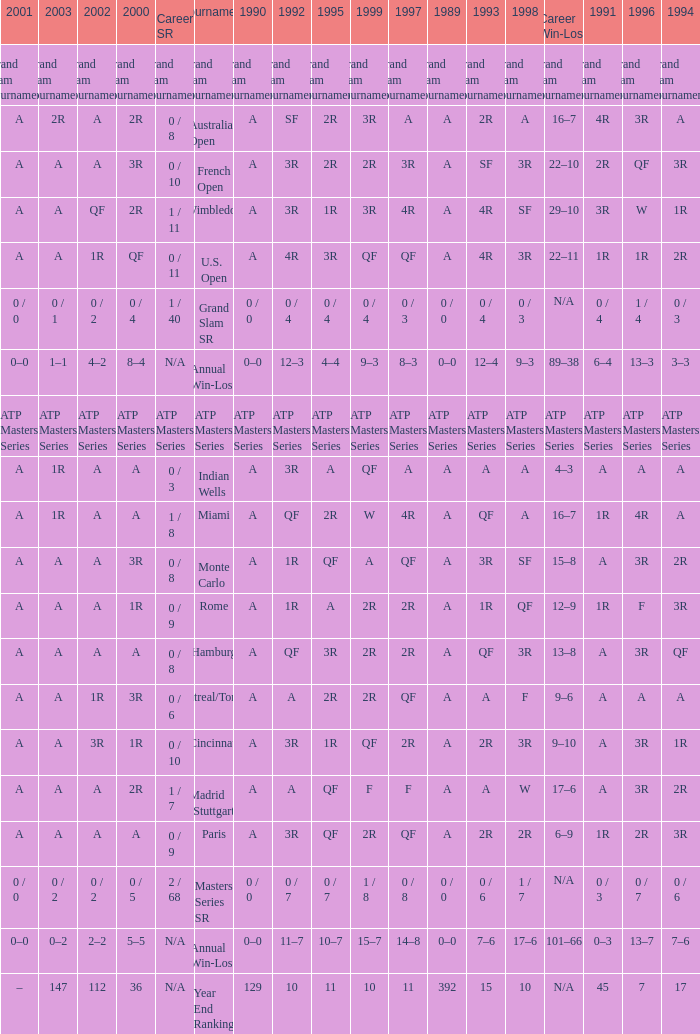In 1997, what is the value if the 1989 value is a, the 1995 value is qf, the 1996 value is 3r, and the career sr equals 0/8? QF. 